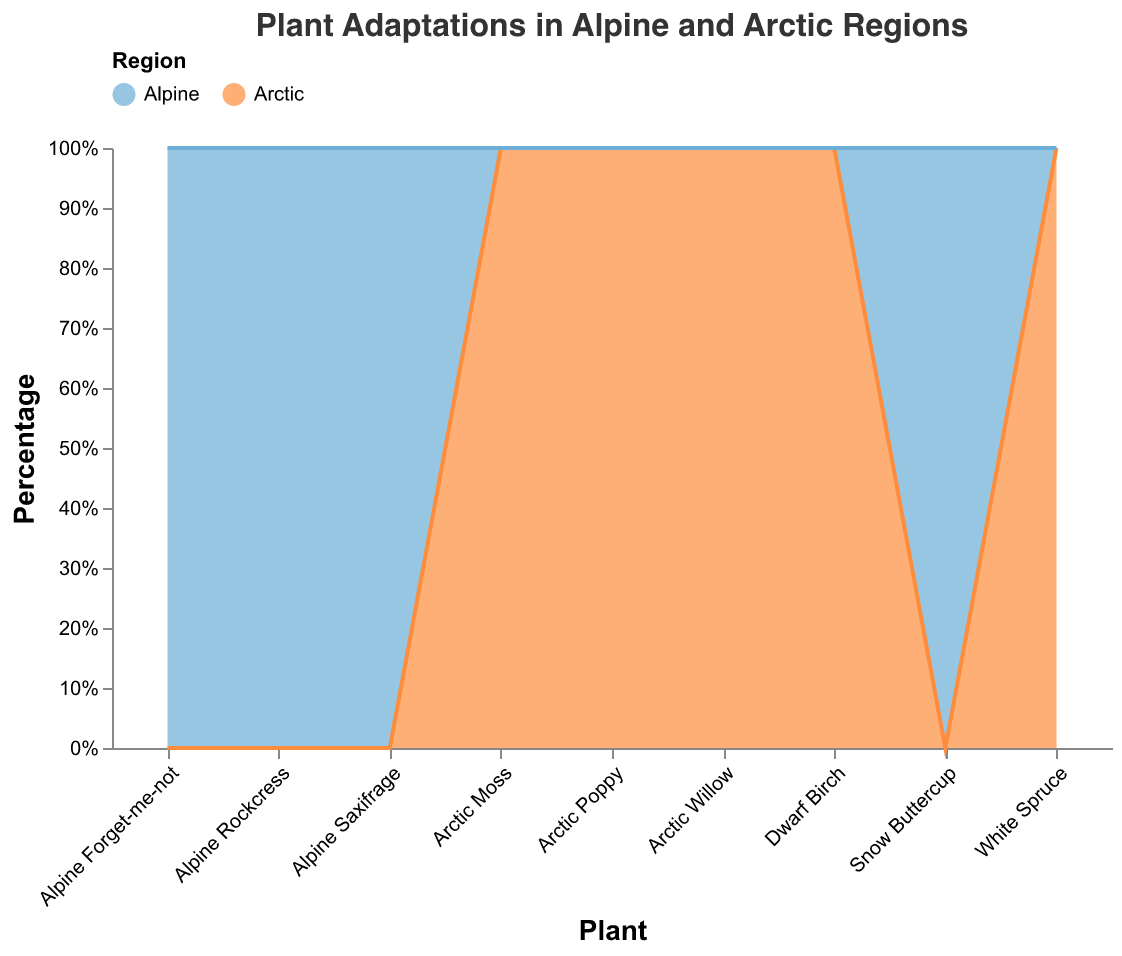What is the title of the chart? The title of the chart is placed at the top and reads "Plant Adaptations in Alpine and Arctic Regions".
Answer: Plant Adaptations in Alpine and Arctic Regions How many regions are represented in the chart? The chart uses colors to show different regions, specifically two colors. The legend indicates the regions: Arctic and Alpine.
Answer: 2 What color represents the Arctic region in the chart? According to the legend, the Arctic region is represented by the color blue.
Answer: Blue Which plant appears to have the highest Leaf Albedo percentage in the Alpine region? The Leaf Albedo percentage for Alpine plants is shown as segments in the chart. Among the Alpine plants, the Alpine Forget-me-not has the highest Leaf Albedo percentage, which is indicated in the tooltip associated with it.
Answer: Alpine Forget-me-not Which region has the plant with the highest Photosynthetic Rate? By hovering over the segments or looking at the tooltip, we can see that the Arctic Poppy, which belongs to the Arctic region, has the highest Photosynthetic Rate of 18.
Answer: Arctic Which plant has the highest Cold Hardiness in the Arctic region? By checking the tooltip for each plant in the Arctic region, Arctic Willow is found to have the highest Cold Hardiness score of 80.
Answer: Arctic Willow Compare the Frost Resistance of Dwarf Birch and Arctic Poppy. Which plant is more resistant? Frost Resistance for both plants can be identified by hovering over their segments. Dwarf Birch has a Frost Resistance of 88, while Arctic Poppy has 89. Therefore, Arctic Poppy is slightly more frost-resistant.
Answer: Arctic Poppy Which adaptation metric shows the greatest range among the Alpine region plants? Measuring the range involves comparing the minimum and maximum values in each adaptation metric for Alpine plants. The range can be inspected in the tooltip values.
- Leaf Albedo: 21 - 24 = 3
- Photosynthetic Rate: 13 - 17 = 4
- Cold Hardiness: 70 - 74 = 4
- Snow Cover Tolerance: 60 - 65 = 5
- Frost Resistance: 80 - 87 = 7
Frost Resistance has the greatest range among the metrics for Alpine plants.
Answer: Frost Resistance What is the average Snow Cover Tolerance for Arctic region plants? The Snow Cover Tolerance values for Arctic plants are 60 (Arctic Willow), 55 (White Spruce), 58 (Dwarf Birch), 62 (Arctic Poppy), and 66 (Arctic Moss). Calculate the sum: 60 + 55 + 58 + 62 + 66 = 301. There are 5 Arctic plants, so the average is 301/5 = 60.2.
Answer: 60.2 